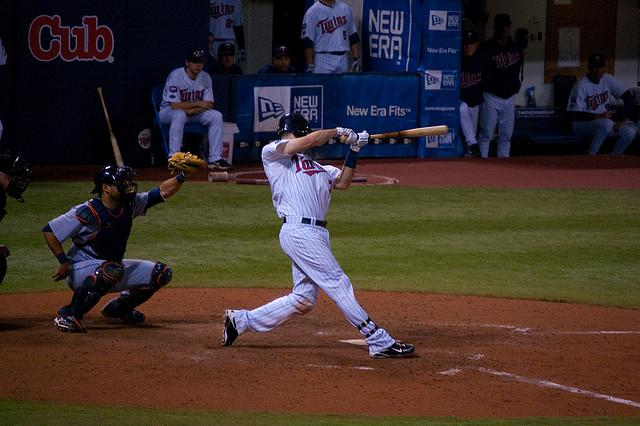What cap/apparel company is a sponsor for the stadium? Please explain your reasoning. new era. New era fits is shown as a logo. 